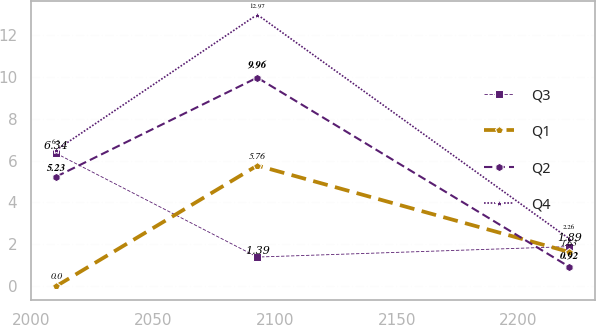Convert chart to OTSL. <chart><loc_0><loc_0><loc_500><loc_500><line_chart><ecel><fcel>Q3<fcel>Q1<fcel>Q2<fcel>Q4<nl><fcel>2010.22<fcel>6.34<fcel>0<fcel>5.23<fcel>6.5<nl><fcel>2092.76<fcel>1.39<fcel>5.76<fcel>9.96<fcel>12.97<nl><fcel>2220.88<fcel>1.89<fcel>1.63<fcel>0.92<fcel>2.26<nl></chart> 